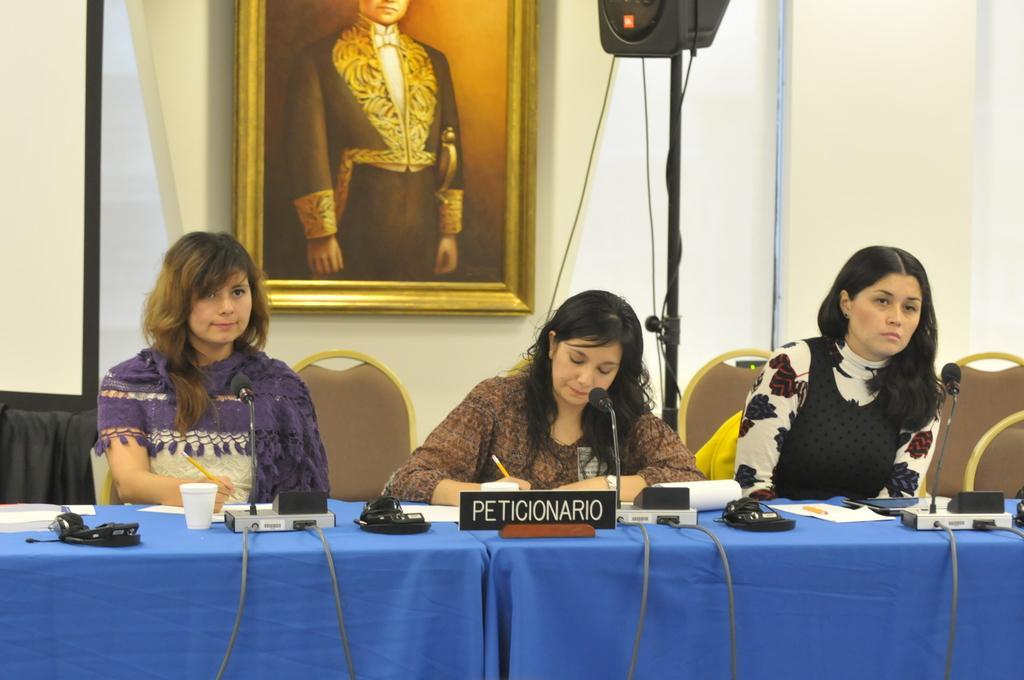In one or two sentences, can you explain what this image depicts? In the image we can see there are women who are sitting on chair and on table there are glass, mic with a stand and paper and pencil. 